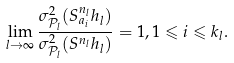Convert formula to latex. <formula><loc_0><loc_0><loc_500><loc_500>\lim _ { l \to \infty } \frac { \sigma ^ { 2 } _ { \mathcal { P } _ { l } } ( S ^ { n _ { l } } _ { a _ { i } } h _ { l } ) } { \sigma ^ { 2 } _ { \mathcal { P } _ { l } } ( S ^ { n _ { l } } h _ { l } ) } = 1 , 1 \leqslant i \leqslant k _ { l } .</formula> 